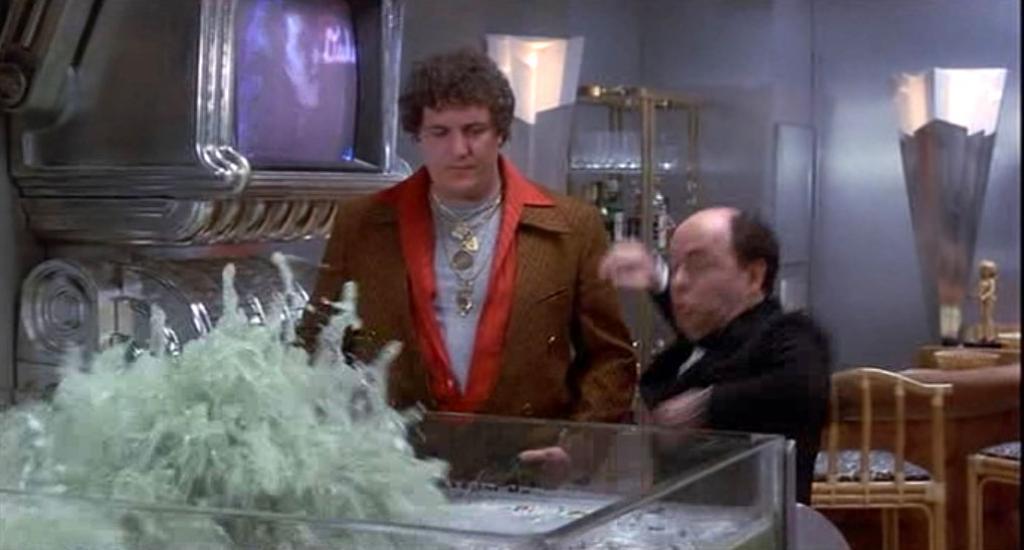Could you give a brief overview of what you see in this image? The photo is taken in a room. There are two persons standing in front of a glass tub. This is a screen. behind the person there is a rack on that there are glasses and bottles. On the right there are some chairs. 